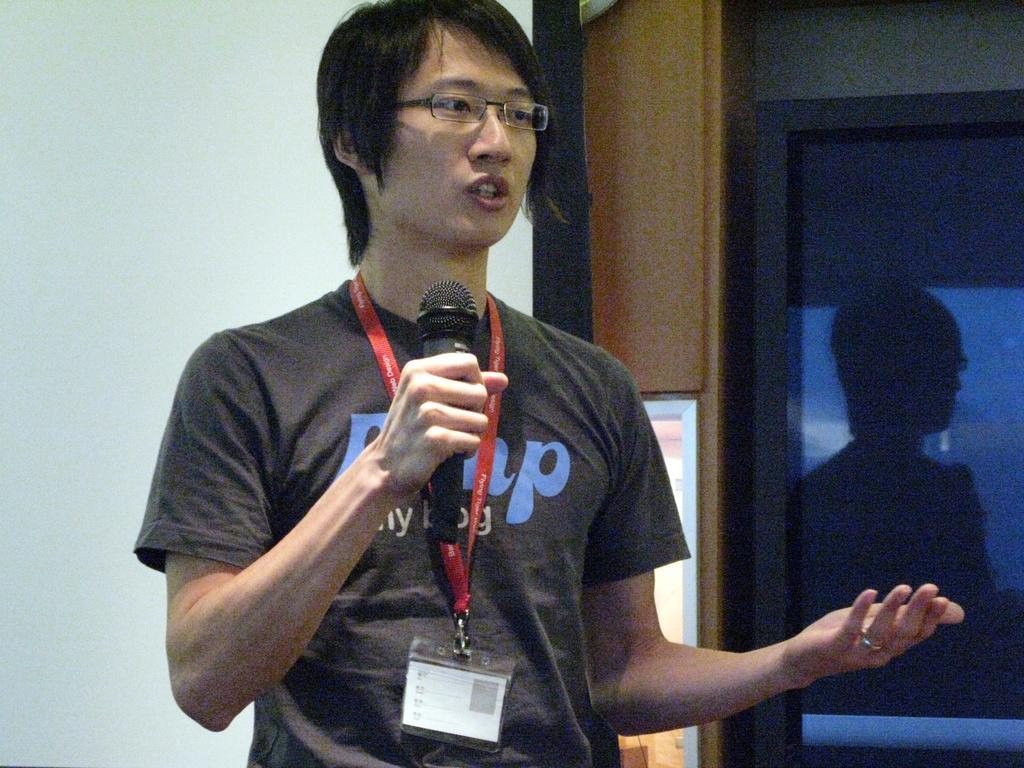In one or two sentences, can you explain what this image depicts? In this image I can see a person wearing t shirt is standing and holding a microphone in his hand which is black in color. In the background I can see the white colored wall, a banner and the glass door in which I can see the reflection of a person. 